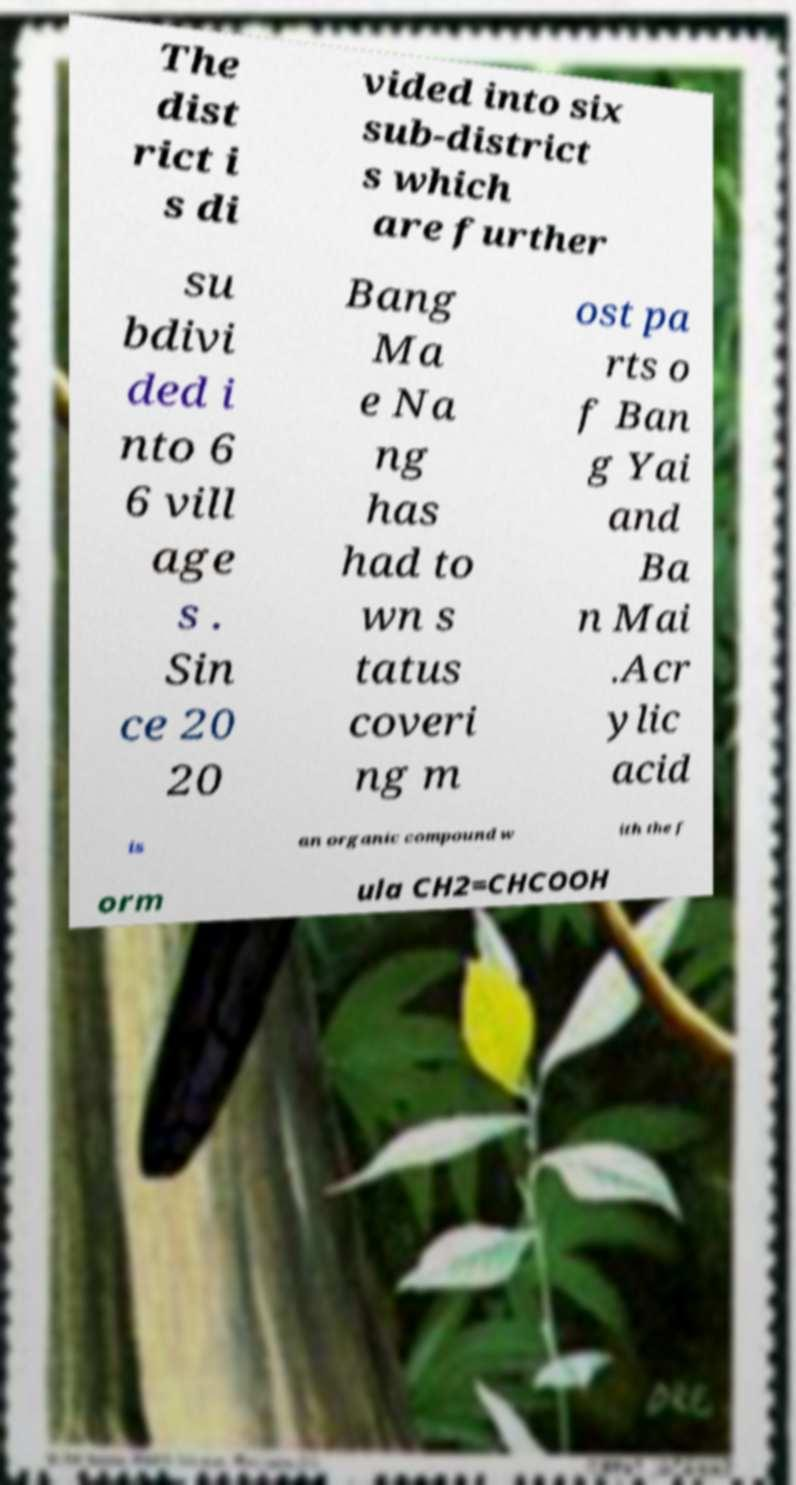Please read and relay the text visible in this image. What does it say? The dist rict i s di vided into six sub-district s which are further su bdivi ded i nto 6 6 vill age s . Sin ce 20 20 Bang Ma e Na ng has had to wn s tatus coveri ng m ost pa rts o f Ban g Yai and Ba n Mai .Acr ylic acid is an organic compound w ith the f orm ula CH2=CHCOOH 